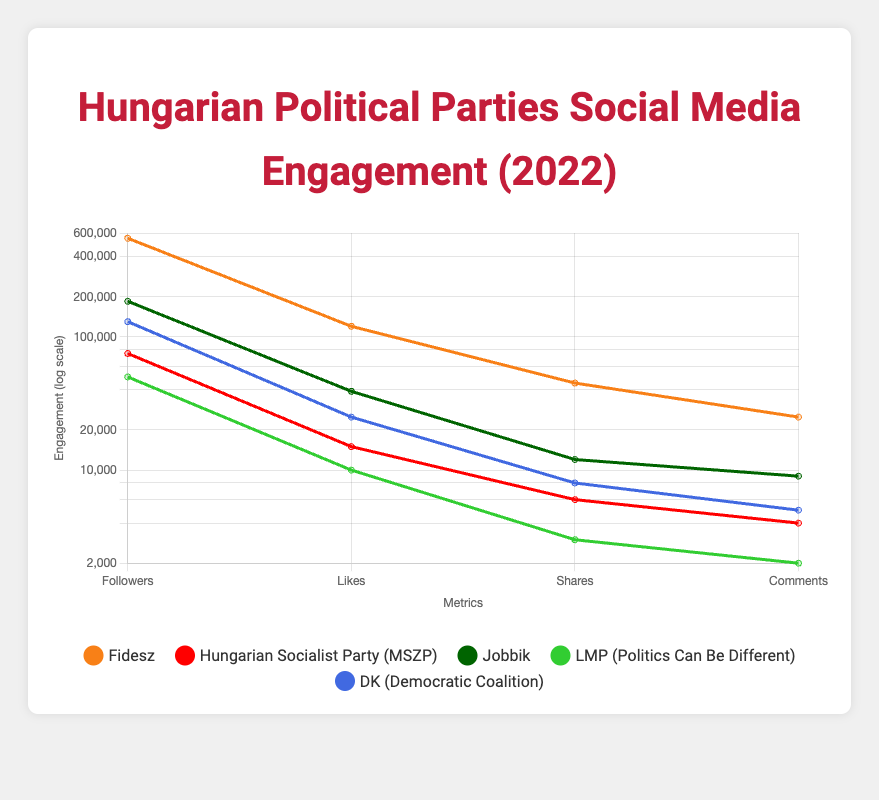What is the total number of followers for all listed political parties? To find the total number of followers, we need to sum the followers of each party: Fidesz (550000) + MSZP (75000) + Jobbik (185000) + LMP (50000) + DK (130000) = 990000.
Answer: 990000 Which political party has the highest number of likes? From the table, Fidesz has the highest likes at 120000, compared to the other parties: MSZP (15000), Jobbik (39000), LMP (10000), and DK (25000).
Answer: Fidesz Is it true that Jobbik has more shares than MSZP? Jobbik has 12000 shares while MSZP has 6000 shares. Since 12000 is greater than 6000, the statement is true.
Answer: Yes What is the average number of comments per party? We need to sum the comments: Fidesz (25000) + MSZP (4000) + Jobbik (9000) + LMP (2000) + DK (5000) = 40000. The average is then calculated as 40000 divided by 5, which equals 8000.
Answer: 8000 Does LMP have more followers than DK? LMP has 50000 followers, and DK has 130000 followers. Comparing these, 50000 is less than 130000, so the statement is false.
Answer: No Which party has the lowest engagement in terms of shares? From the engagement metrics, LMP has the lowest shares at 3000, compared to others: Fidesz (45000), MSZP (6000), Jobbik (12000), and DK (8000).
Answer: LMP What is the difference in the number of likes between Fidesz and Jobbik? Fidesz has 120000 likes and Jobbik has 39000 likes. The difference is 120000 - 39000 = 81000.
Answer: 81000 If you combined the comments from DK and MSZP, would it exceed the comments of Fidesz? DK has 5000 comments and MSZP has 4000 comments, totaling 5000 + 4000 = 9000 comments. Fidesz has 25000 comments, which is greater than 9000. Thus, it does not exceed Fidesz's comments.
Answer: No 